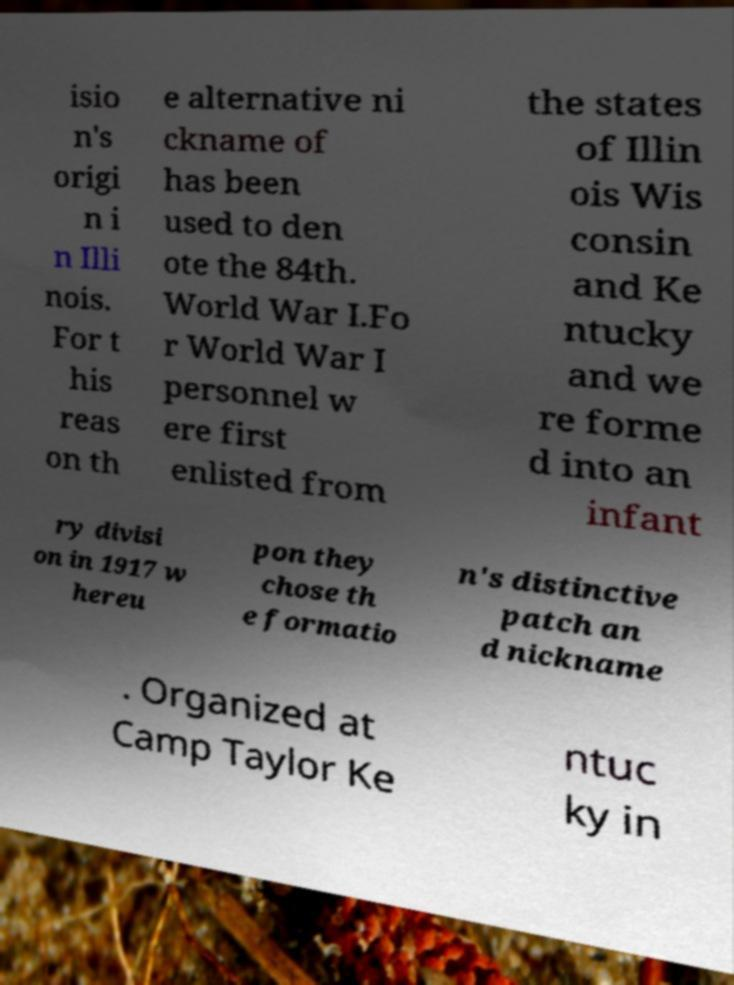Please read and relay the text visible in this image. What does it say? isio n's origi n i n Illi nois. For t his reas on th e alternative ni ckname of has been used to den ote the 84th. World War I.Fo r World War I personnel w ere first enlisted from the states of Illin ois Wis consin and Ke ntucky and we re forme d into an infant ry divisi on in 1917 w hereu pon they chose th e formatio n's distinctive patch an d nickname . Organized at Camp Taylor Ke ntuc ky in 